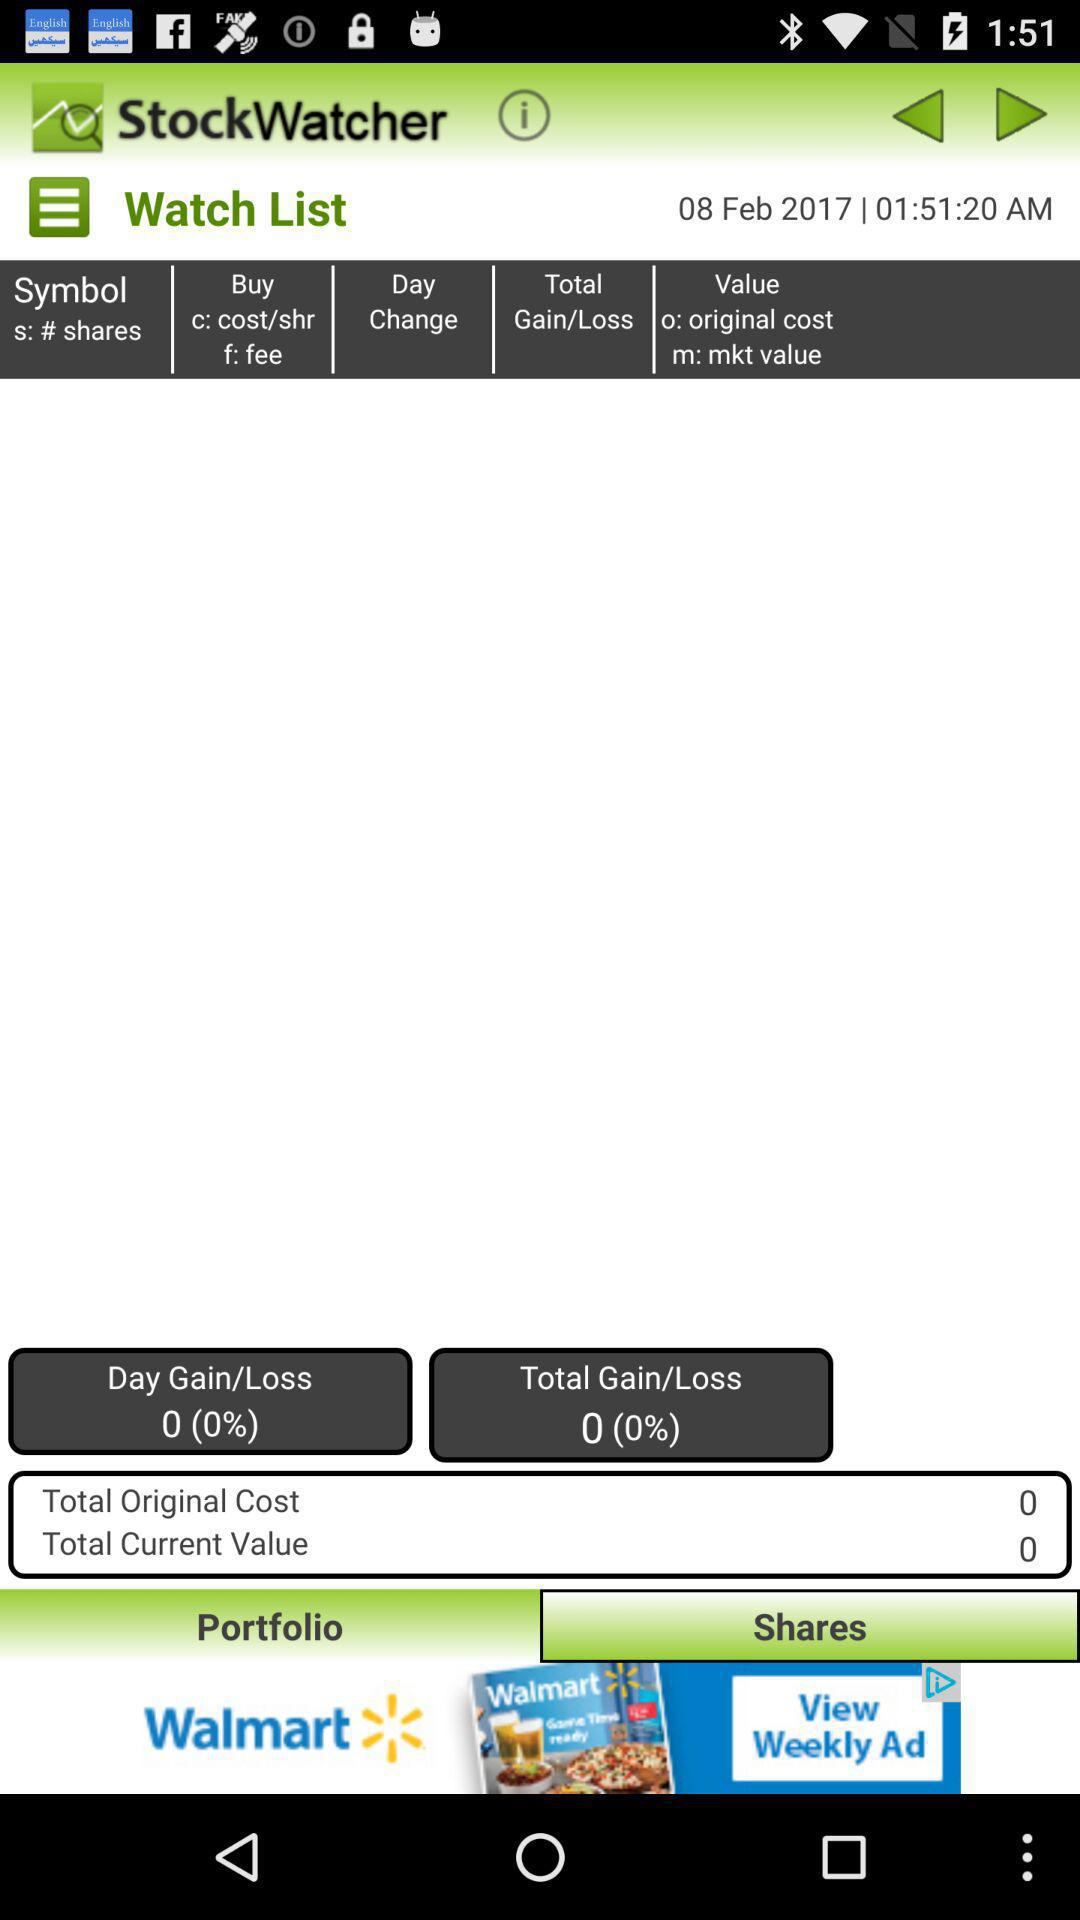What is the percentage of total gain/loss? The percentage of total gain/loss is 0. 